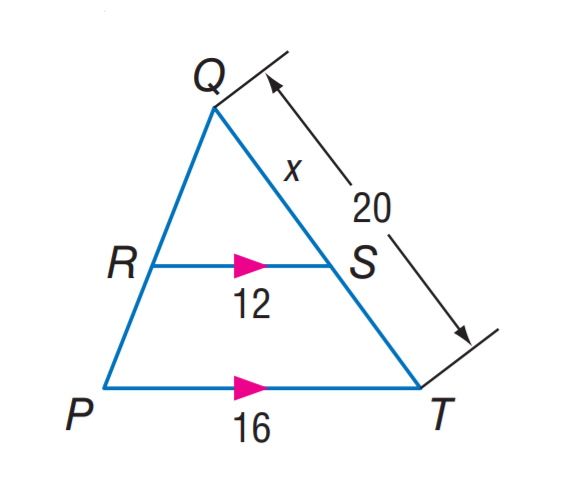Answer the mathemtical geometry problem and directly provide the correct option letter.
Question: Find S T.
Choices: A: 5 B: 10 C: 12 D: 16 A 